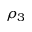Convert formula to latex. <formula><loc_0><loc_0><loc_500><loc_500>\rho _ { 3 }</formula> 